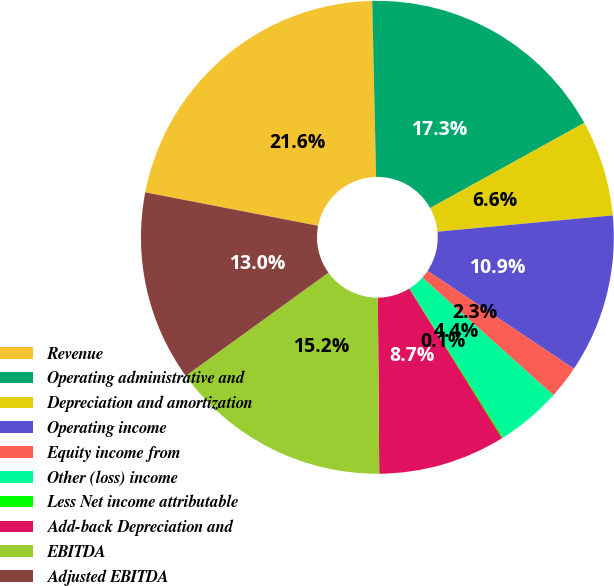<chart> <loc_0><loc_0><loc_500><loc_500><pie_chart><fcel>Revenue<fcel>Operating administrative and<fcel>Depreciation and amortization<fcel>Operating income<fcel>Equity income from<fcel>Other (loss) income<fcel>Less Net income attributable<fcel>Add-back Depreciation and<fcel>EBITDA<fcel>Adjusted EBITDA<nl><fcel>21.61%<fcel>17.31%<fcel>6.56%<fcel>10.86%<fcel>2.26%<fcel>4.41%<fcel>0.11%<fcel>8.71%<fcel>15.16%<fcel>13.01%<nl></chart> 